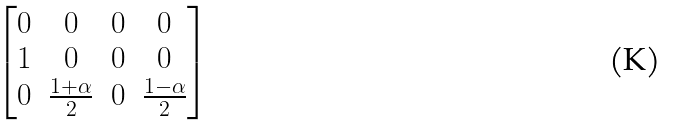Convert formula to latex. <formula><loc_0><loc_0><loc_500><loc_500>\begin{bmatrix} 0 & 0 & 0 & 0 \\ 1 & 0 & 0 & 0 \\ 0 & \frac { 1 + \alpha } { 2 } & 0 & \frac { 1 - \alpha } { 2 } \end{bmatrix}</formula> 